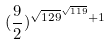<formula> <loc_0><loc_0><loc_500><loc_500>( \frac { 9 } { 2 } ) ^ { \sqrt { 1 2 9 } ^ { \sqrt { 1 1 9 } } + 1 }</formula> 